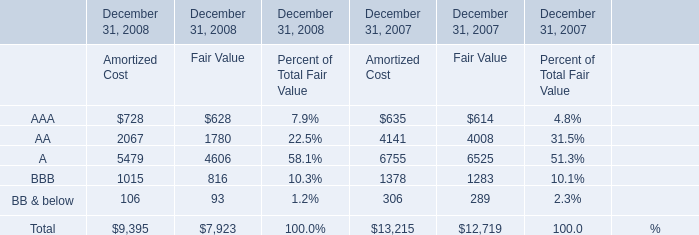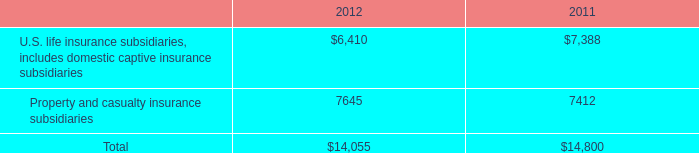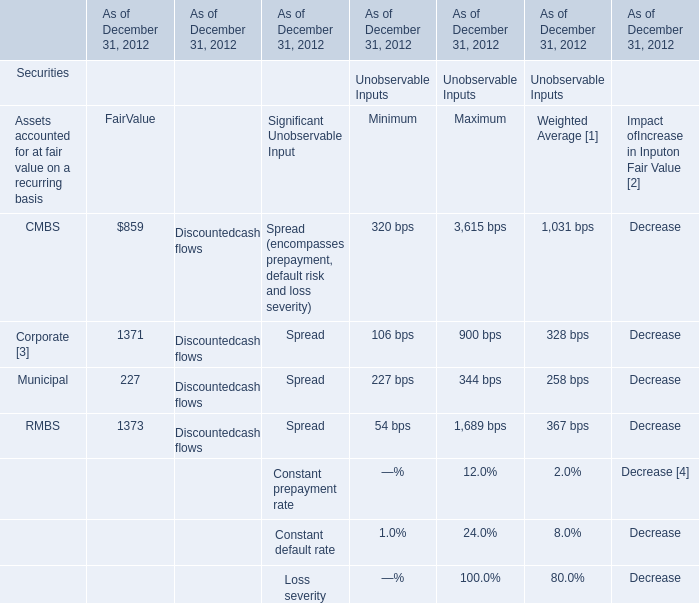What's the average of Property and casualty insurance subsidiaries of 2011, and Corporate [3] of As of December 31, 2012 FairValue ? 
Computations: ((7412.0 + 1371.0) / 2)
Answer: 4391.5. 